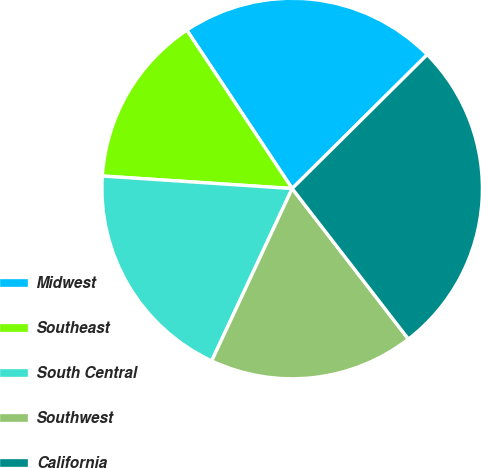<chart> <loc_0><loc_0><loc_500><loc_500><pie_chart><fcel>Midwest<fcel>Southeast<fcel>South Central<fcel>Southwest<fcel>California<nl><fcel>21.91%<fcel>14.61%<fcel>19.1%<fcel>17.42%<fcel>26.97%<nl></chart> 